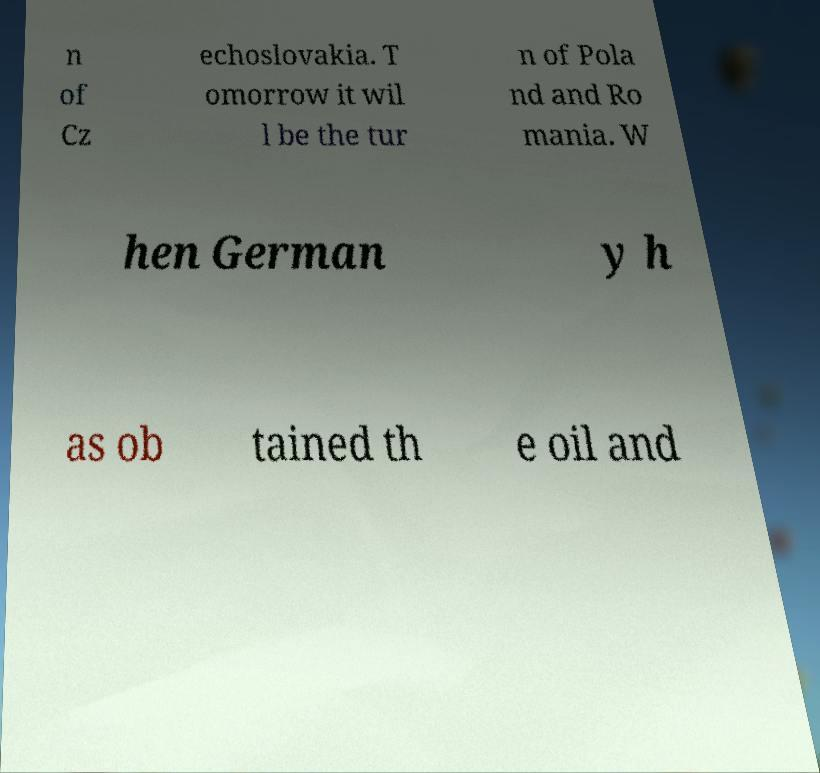Can you accurately transcribe the text from the provided image for me? n of Cz echoslovakia. T omorrow it wil l be the tur n of Pola nd and Ro mania. W hen German y h as ob tained th e oil and 